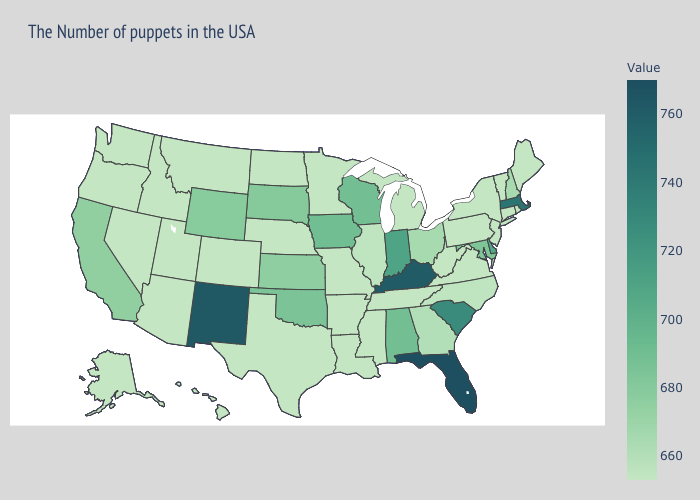Which states have the lowest value in the MidWest?
Short answer required. Michigan, Missouri, Minnesota, Nebraska, North Dakota. Does Wisconsin have the lowest value in the USA?
Answer briefly. No. Which states have the lowest value in the USA?
Quick response, please. Maine, Rhode Island, Vermont, Connecticut, New York, New Jersey, Pennsylvania, Virginia, West Virginia, Michigan, Tennessee, Mississippi, Louisiana, Missouri, Arkansas, Minnesota, Nebraska, Texas, North Dakota, Colorado, Utah, Montana, Arizona, Idaho, Nevada, Washington, Oregon, Alaska, Hawaii. Does the map have missing data?
Give a very brief answer. No. Does the map have missing data?
Be succinct. No. Among the states that border Wyoming , does Utah have the highest value?
Be succinct. No. Which states have the lowest value in the USA?
Write a very short answer. Maine, Rhode Island, Vermont, Connecticut, New York, New Jersey, Pennsylvania, Virginia, West Virginia, Michigan, Tennessee, Mississippi, Louisiana, Missouri, Arkansas, Minnesota, Nebraska, Texas, North Dakota, Colorado, Utah, Montana, Arizona, Idaho, Nevada, Washington, Oregon, Alaska, Hawaii. Among the states that border Florida , does Georgia have the highest value?
Quick response, please. No. 